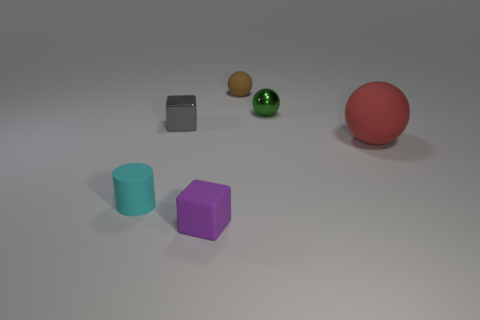Are there the same number of red rubber things and tiny spheres?
Your answer should be compact. No. What is the shape of the rubber object that is behind the rubber ball that is in front of the metallic sphere?
Ensure brevity in your answer.  Sphere. Do the block in front of the cyan thing and the sphere that is in front of the tiny shiny cube have the same color?
Your answer should be very brief. No. Is there anything else that has the same color as the big rubber thing?
Offer a terse response. No. What color is the tiny cylinder?
Make the answer very short. Cyan. Are there any matte cylinders?
Make the answer very short. Yes. There is a purple matte thing; are there any purple cubes in front of it?
Offer a terse response. No. There is another brown object that is the same shape as the big rubber thing; what is its material?
Offer a very short reply. Rubber. Are there any other things that are the same material as the small brown thing?
Offer a terse response. Yes. How many other objects are there of the same shape as the small green object?
Your response must be concise. 2. 